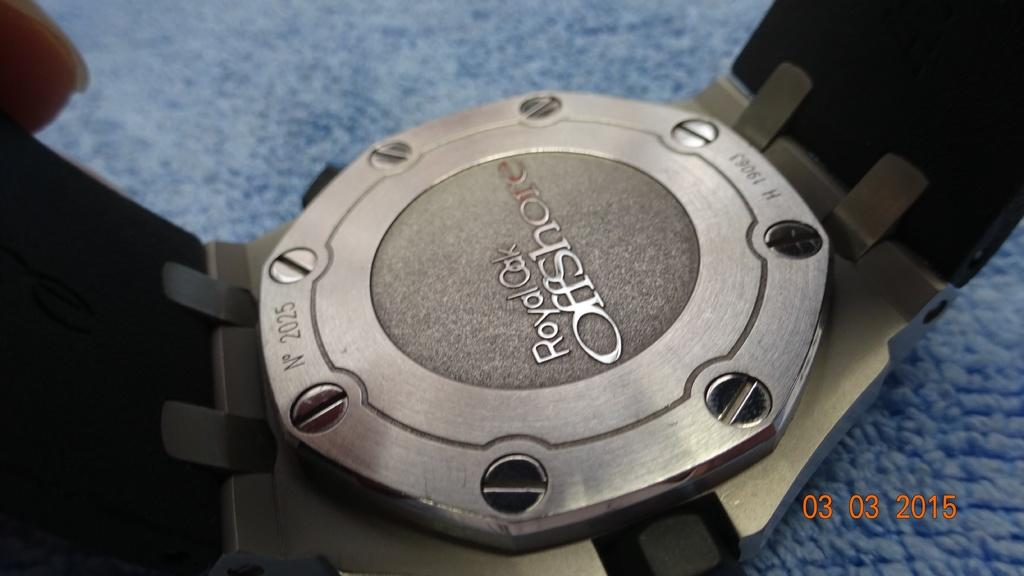<image>
Share a concise interpretation of the image provided. A silver colored metal device is a Royal Oak Offshore brand. 